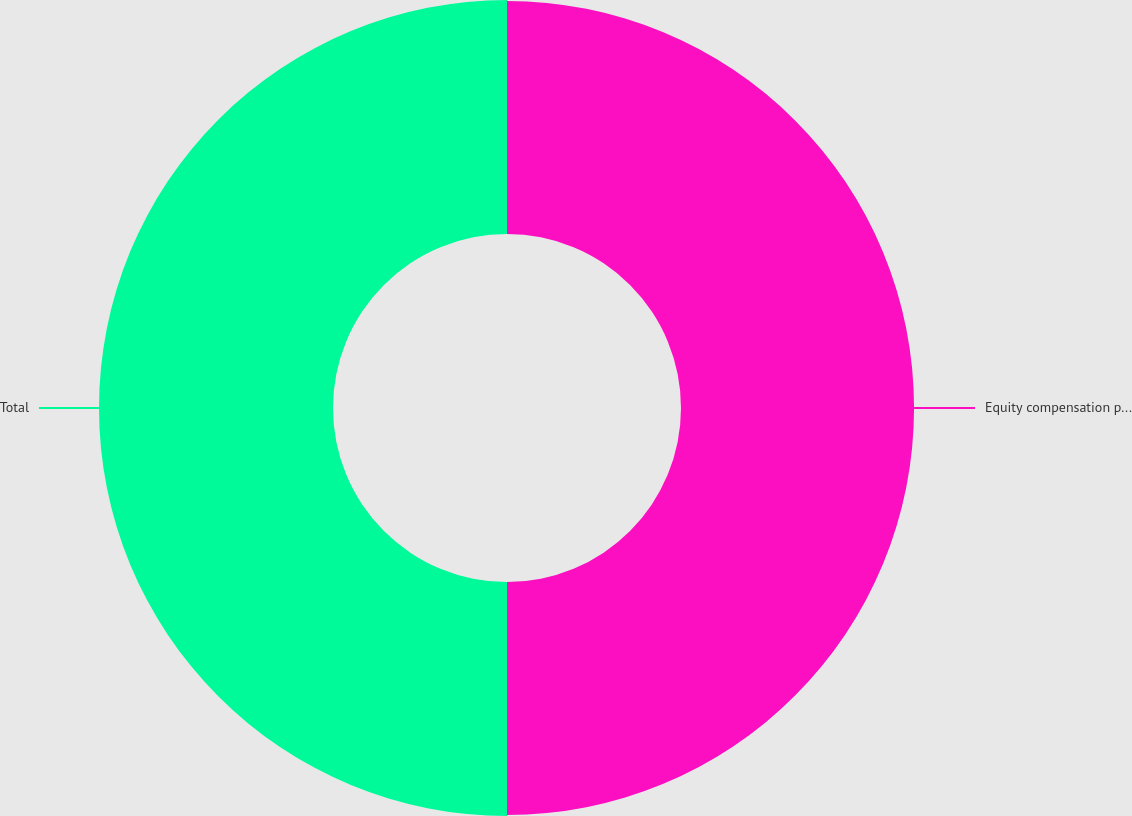<chart> <loc_0><loc_0><loc_500><loc_500><pie_chart><fcel>Equity compensation plans<fcel>Total<nl><fcel>49.9%<fcel>50.1%<nl></chart> 